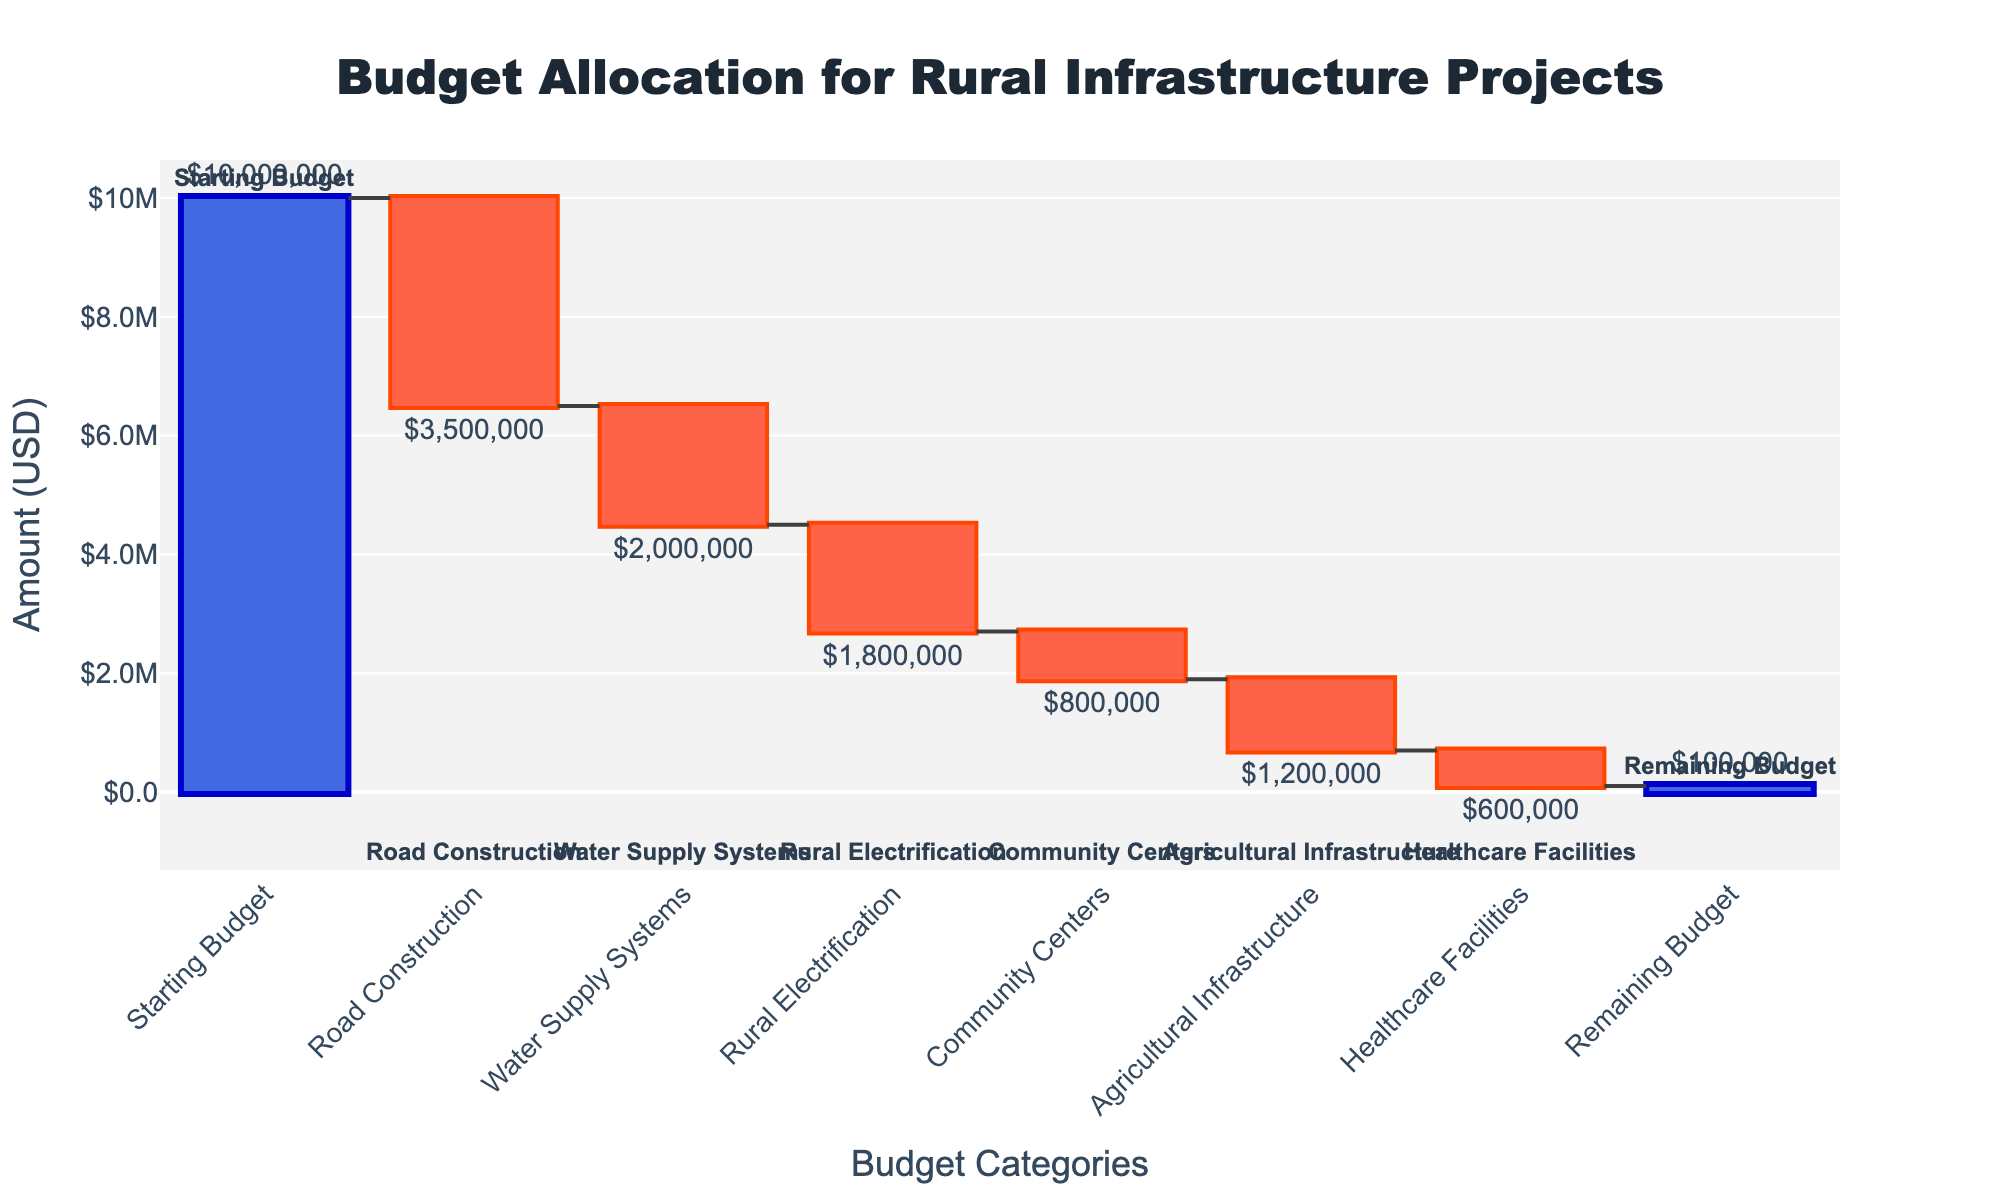What's the title of the chart? The title of the chart is prominently displayed at the top and reads "Budget Allocation for Rural Infrastructure Projects".
Answer: Budget Allocation for Rural Infrastructure Projects What is the amount allocated to Road Construction? The amount for "Road Construction" is indicated in the waterfall chart as a negative value next to the category. It reads -$3,500,000.
Answer: -$3,500,000 What is the total amount spent on Agricultural Infrastructure and Healthcare Facilities? The amount allocated to Agricultural Infrastructure is -$1,200,000 and to Healthcare Facilities is -$600,000. Summing them up gives -$1,800,000.
Answer: -$1,800,000 Which project category consumes the highest budget? By looking at the descending bars, "Road Construction" has the largest negative value, indicating the highest budget consumption of -$3,500,000.
Answer: Road Construction What is the remaining budget after all allocations? The remaining budget is the last value in the waterfall chart, which is displayed as "$100,000".
Answer: $100,000 How much more was spent on Road Construction compared to Rural Electrification? The expenditure on Road Construction is -$3,500,000 and on Rural Electrification is -$1,800,000. The difference is -$3,500,000 - (-$1,800,000) = -$1,700,000.
Answer: $1,700,000 Which categories have a budget allocation between -$1,000,000 and -$2,000,000? "Rural Electrification" and "Agricultural Infrastructure" have allocations of -$1,800,000 and -$1,200,000, respectively. Both fall between -$1,000,000 and -$2,000,000.
Answer: Rural Electrification, Agricultural Infrastructure How does the budget allocation for Community Centers compare to Healthcare Facilities? Community Centers have an allocation of -$800,000, while Healthcare Facilities have -$600,000. Community Centers have a higher allocation by $200,000.
Answer: Higher by $200,000 What is the percentage of the remaining budget compared to the Starting Budget? The remaining budget is $100,000, and the starting budget is $10,000,000. The percentage is ($100,000 / $10,000,000) * 100 = 1%.
Answer: 1% 